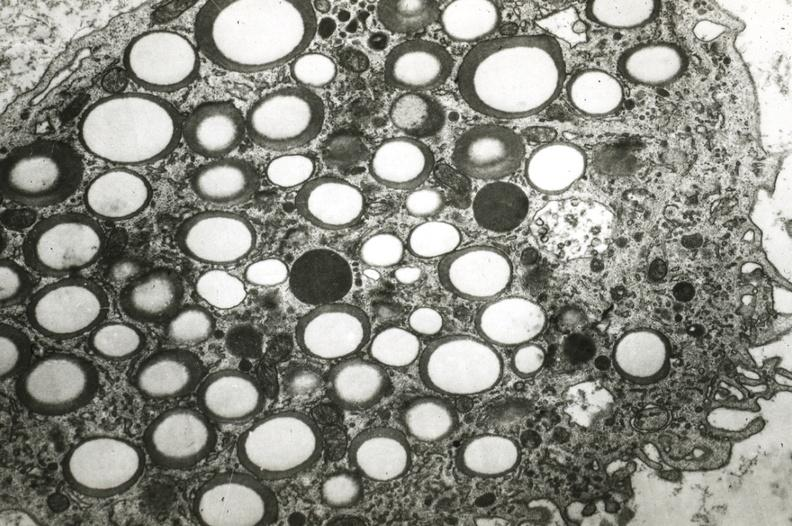what is present?
Answer the question using a single word or phrase. Coronary artery 